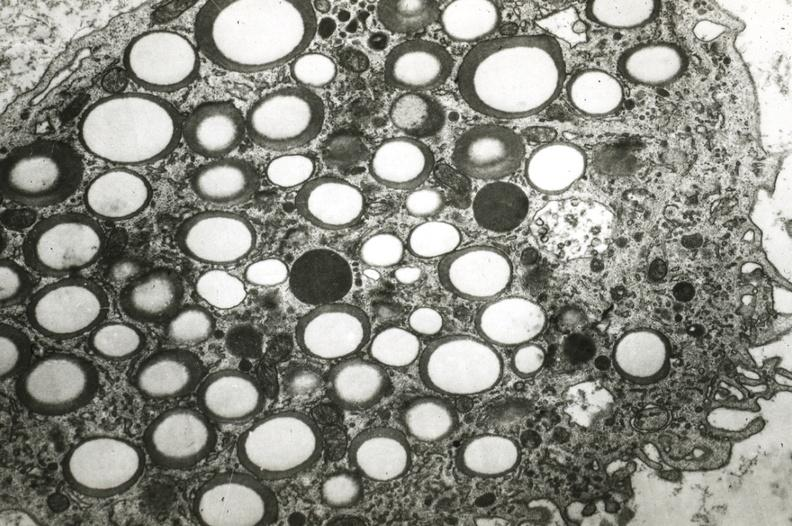what is present?
Answer the question using a single word or phrase. Coronary artery 